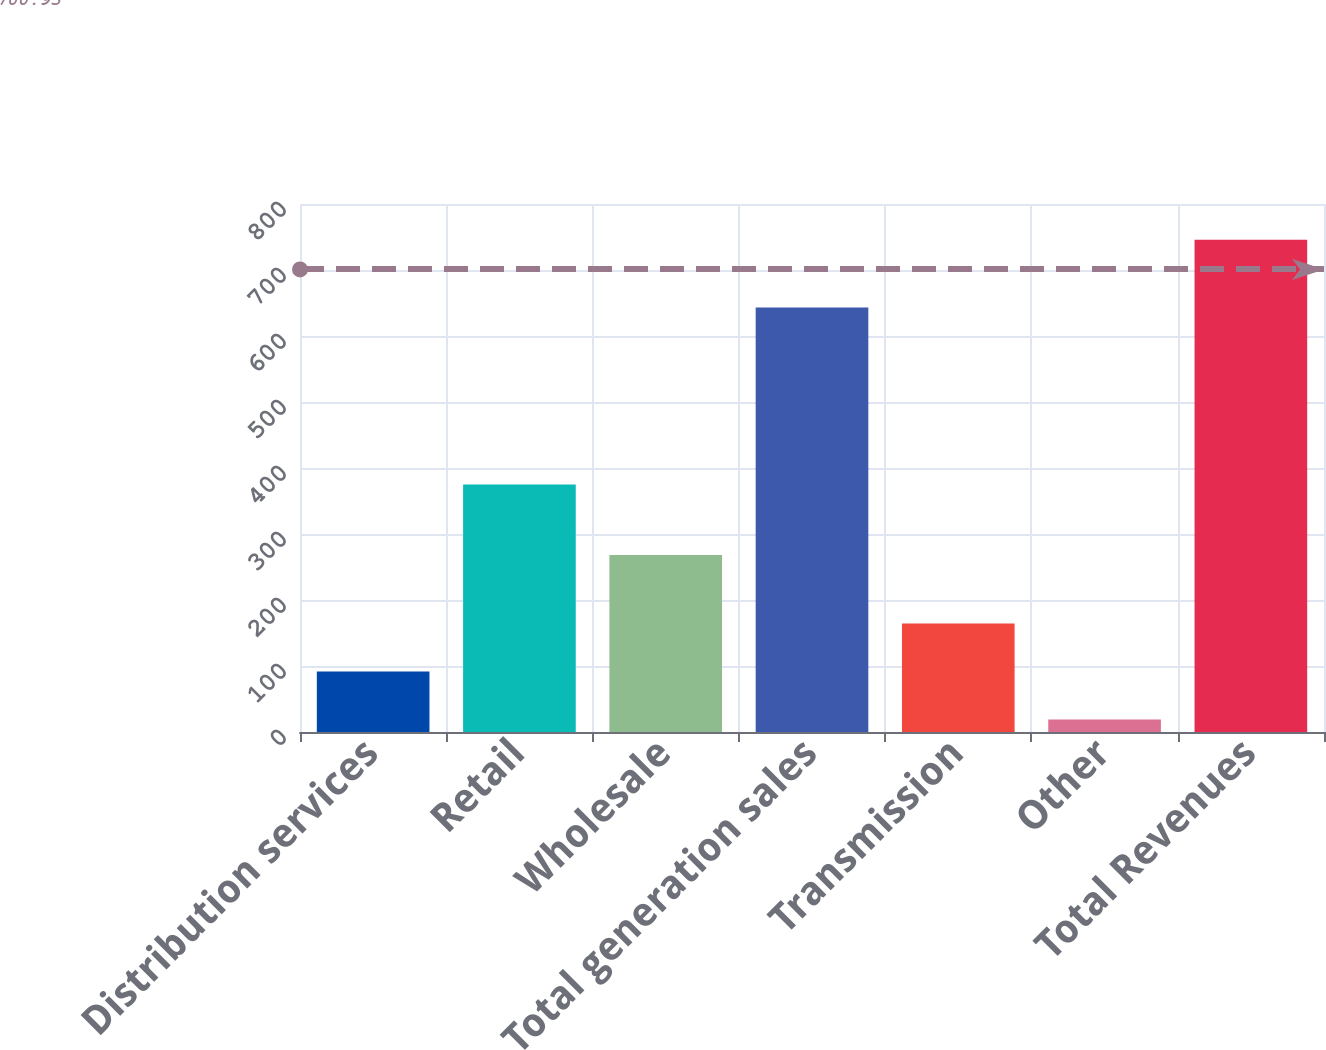<chart> <loc_0><loc_0><loc_500><loc_500><bar_chart><fcel>Distribution services<fcel>Retail<fcel>Wholesale<fcel>Total generation sales<fcel>Transmission<fcel>Other<fcel>Total Revenues<nl><fcel>91.7<fcel>375<fcel>268<fcel>643<fcel>164.4<fcel>19<fcel>746<nl></chart> 